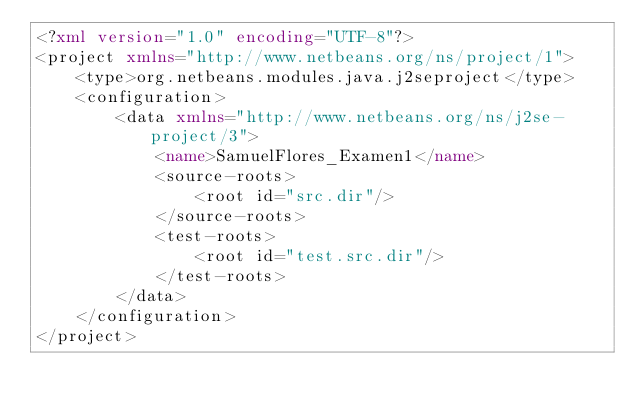<code> <loc_0><loc_0><loc_500><loc_500><_XML_><?xml version="1.0" encoding="UTF-8"?>
<project xmlns="http://www.netbeans.org/ns/project/1">
    <type>org.netbeans.modules.java.j2seproject</type>
    <configuration>
        <data xmlns="http://www.netbeans.org/ns/j2se-project/3">
            <name>SamuelFlores_Examen1</name>
            <source-roots>
                <root id="src.dir"/>
            </source-roots>
            <test-roots>
                <root id="test.src.dir"/>
            </test-roots>
        </data>
    </configuration>
</project>
</code> 